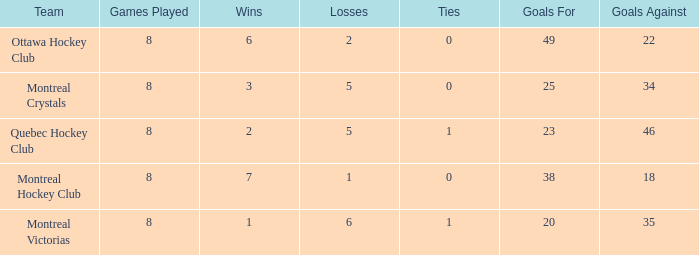What is the average ties when the team is montreal victorias and the games played is more than 8? None. 